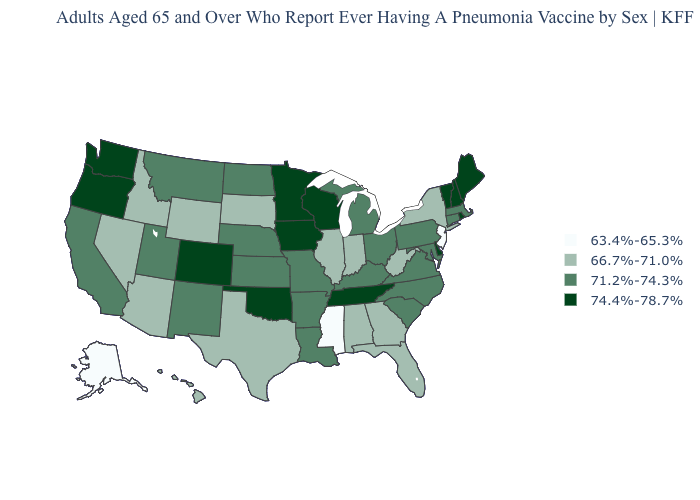Does the first symbol in the legend represent the smallest category?
Give a very brief answer. Yes. What is the highest value in the MidWest ?
Short answer required. 74.4%-78.7%. Is the legend a continuous bar?
Be succinct. No. Does Illinois have the highest value in the MidWest?
Answer briefly. No. Name the states that have a value in the range 71.2%-74.3%?
Answer briefly. Arkansas, California, Connecticut, Kansas, Kentucky, Louisiana, Maryland, Massachusetts, Michigan, Missouri, Montana, Nebraska, New Mexico, North Carolina, North Dakota, Ohio, Pennsylvania, South Carolina, Utah, Virginia. What is the value of Iowa?
Quick response, please. 74.4%-78.7%. What is the lowest value in states that border Maryland?
Answer briefly. 66.7%-71.0%. What is the value of Georgia?
Answer briefly. 66.7%-71.0%. Name the states that have a value in the range 71.2%-74.3%?
Short answer required. Arkansas, California, Connecticut, Kansas, Kentucky, Louisiana, Maryland, Massachusetts, Michigan, Missouri, Montana, Nebraska, New Mexico, North Carolina, North Dakota, Ohio, Pennsylvania, South Carolina, Utah, Virginia. What is the value of North Carolina?
Write a very short answer. 71.2%-74.3%. How many symbols are there in the legend?
Keep it brief. 4. Does Kansas have a lower value than South Dakota?
Concise answer only. No. Does Delaware have the lowest value in the USA?
Quick response, please. No. What is the highest value in the USA?
Write a very short answer. 74.4%-78.7%. Does Maryland have a lower value than Idaho?
Be succinct. No. 